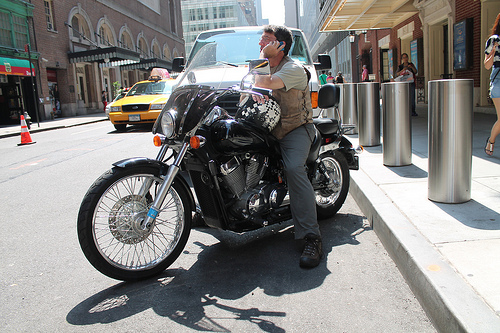Do you see any motorcycles or trash cans? Yes, there is a motorcycle in the forefront, and two metallic trash cans are also present on the sidewalk. 